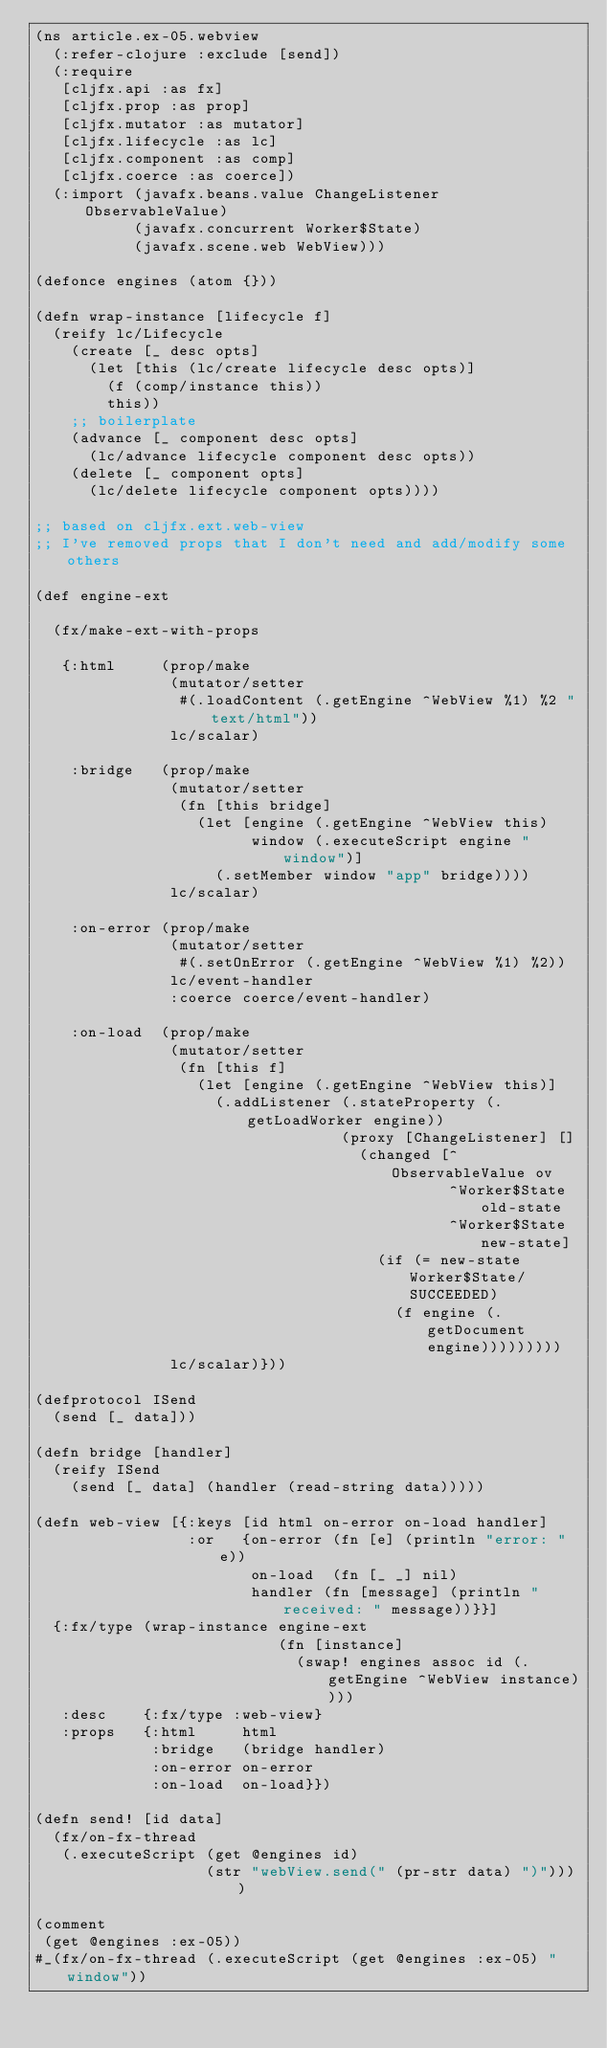Convert code to text. <code><loc_0><loc_0><loc_500><loc_500><_Clojure_>(ns article.ex-05.webview
  (:refer-clojure :exclude [send])
  (:require
   [cljfx.api :as fx]
   [cljfx.prop :as prop]
   [cljfx.mutator :as mutator]
   [cljfx.lifecycle :as lc]
   [cljfx.component :as comp]
   [cljfx.coerce :as coerce])
  (:import (javafx.beans.value ChangeListener ObservableValue)
           (javafx.concurrent Worker$State)
           (javafx.scene.web WebView)))

(defonce engines (atom {}))

(defn wrap-instance [lifecycle f]
  (reify lc/Lifecycle
    (create [_ desc opts]
      (let [this (lc/create lifecycle desc opts)]
        (f (comp/instance this))
        this))
    ;; boilerplate
    (advance [_ component desc opts]
      (lc/advance lifecycle component desc opts))
    (delete [_ component opts]
      (lc/delete lifecycle component opts))))

;; based on cljfx.ext.web-view
;; I've removed props that I don't need and add/modify some others

(def engine-ext

  (fx/make-ext-with-props

   {:html     (prop/make
               (mutator/setter
                #(.loadContent (.getEngine ^WebView %1) %2 "text/html"))
               lc/scalar)

    :bridge   (prop/make
               (mutator/setter
                (fn [this bridge]
                  (let [engine (.getEngine ^WebView this)
                        window (.executeScript engine "window")]
                    (.setMember window "app" bridge))))
               lc/scalar)

    :on-error (prop/make
               (mutator/setter
                #(.setOnError (.getEngine ^WebView %1) %2))
               lc/event-handler
               :coerce coerce/event-handler)

    :on-load  (prop/make
               (mutator/setter
                (fn [this f]
                  (let [engine (.getEngine ^WebView this)]
                    (.addListener (.stateProperty (.getLoadWorker engine))
                                  (proxy [ChangeListener] []
                                    (changed [^ObservableValue ov
                                              ^Worker$State old-state
                                              ^Worker$State new-state]
                                      (if (= new-state Worker$State/SUCCEEDED)
                                        (f engine (.getDocument engine)))))))))
               lc/scalar)}))

(defprotocol ISend
  (send [_ data]))

(defn bridge [handler]
  (reify ISend
    (send [_ data] (handler (read-string data)))))

(defn web-view [{:keys [id html on-error on-load handler]
                 :or   {on-error (fn [e] (println "error: " e))
                        on-load  (fn [_ _] nil)
                        handler (fn [message] (println "received: " message))}}]
  {:fx/type (wrap-instance engine-ext
                           (fn [instance]
                             (swap! engines assoc id (.getEngine ^WebView instance))))
   :desc    {:fx/type :web-view}
   :props   {:html     html
             :bridge   (bridge handler)
             :on-error on-error
             :on-load  on-load}})

(defn send! [id data]
  (fx/on-fx-thread
   (.executeScript (get @engines id)
                   (str "webView.send(" (pr-str data) ")"))))

(comment
 (get @engines :ex-05))
#_(fx/on-fx-thread (.executeScript (get @engines :ex-05) "window"))</code> 